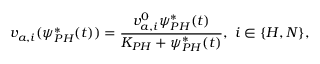Convert formula to latex. <formula><loc_0><loc_0><loc_500><loc_500>v _ { a , i } ( \psi _ { P H } ^ { * } ( t ) ) = \frac { v _ { a , i } ^ { 0 } \psi _ { P H } ^ { * } ( t ) } { K _ { P H } + \psi _ { P H } ^ { * } ( t ) } , \ i \in \{ H , N \} ,</formula> 